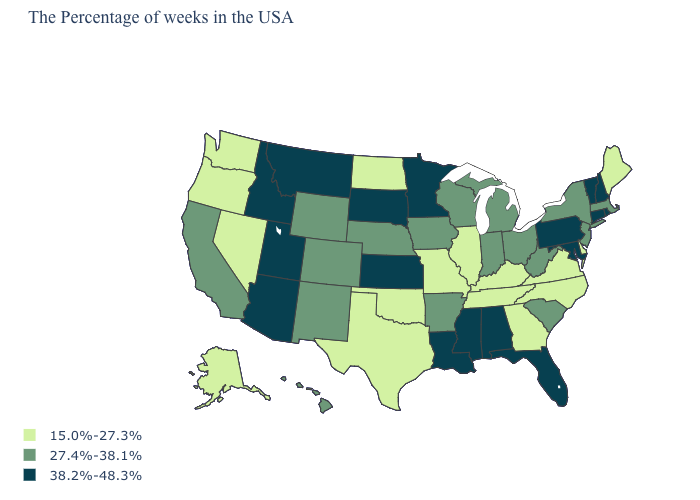Does the map have missing data?
Keep it brief. No. Name the states that have a value in the range 15.0%-27.3%?
Short answer required. Maine, Delaware, Virginia, North Carolina, Georgia, Kentucky, Tennessee, Illinois, Missouri, Oklahoma, Texas, North Dakota, Nevada, Washington, Oregon, Alaska. Which states have the highest value in the USA?
Be succinct. Rhode Island, New Hampshire, Vermont, Connecticut, Maryland, Pennsylvania, Florida, Alabama, Mississippi, Louisiana, Minnesota, Kansas, South Dakota, Utah, Montana, Arizona, Idaho. Does Arizona have the lowest value in the West?
Short answer required. No. Name the states that have a value in the range 15.0%-27.3%?
Answer briefly. Maine, Delaware, Virginia, North Carolina, Georgia, Kentucky, Tennessee, Illinois, Missouri, Oklahoma, Texas, North Dakota, Nevada, Washington, Oregon, Alaska. Does Massachusetts have the highest value in the Northeast?
Quick response, please. No. What is the value of Utah?
Give a very brief answer. 38.2%-48.3%. What is the value of Nevada?
Give a very brief answer. 15.0%-27.3%. Name the states that have a value in the range 38.2%-48.3%?
Quick response, please. Rhode Island, New Hampshire, Vermont, Connecticut, Maryland, Pennsylvania, Florida, Alabama, Mississippi, Louisiana, Minnesota, Kansas, South Dakota, Utah, Montana, Arizona, Idaho. Name the states that have a value in the range 15.0%-27.3%?
Give a very brief answer. Maine, Delaware, Virginia, North Carolina, Georgia, Kentucky, Tennessee, Illinois, Missouri, Oklahoma, Texas, North Dakota, Nevada, Washington, Oregon, Alaska. What is the lowest value in the West?
Short answer required. 15.0%-27.3%. Is the legend a continuous bar?
Concise answer only. No. Is the legend a continuous bar?
Give a very brief answer. No. 